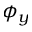Convert formula to latex. <formula><loc_0><loc_0><loc_500><loc_500>\phi _ { y }</formula> 